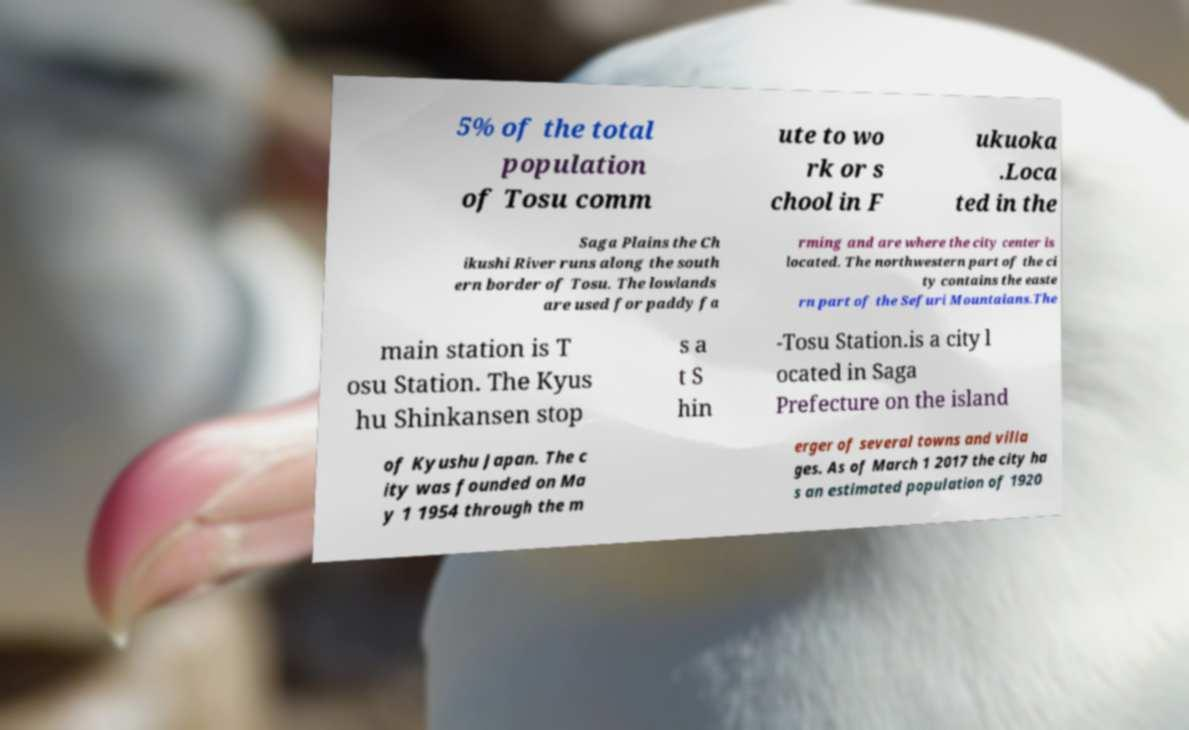Please read and relay the text visible in this image. What does it say? 5% of the total population of Tosu comm ute to wo rk or s chool in F ukuoka .Loca ted in the Saga Plains the Ch ikushi River runs along the south ern border of Tosu. The lowlands are used for paddy fa rming and are where the city center is located. The northwestern part of the ci ty contains the easte rn part of the Sefuri Mountaians.The main station is T osu Station. The Kyus hu Shinkansen stop s a t S hin -Tosu Station.is a city l ocated in Saga Prefecture on the island of Kyushu Japan. The c ity was founded on Ma y 1 1954 through the m erger of several towns and villa ges. As of March 1 2017 the city ha s an estimated population of 1920 